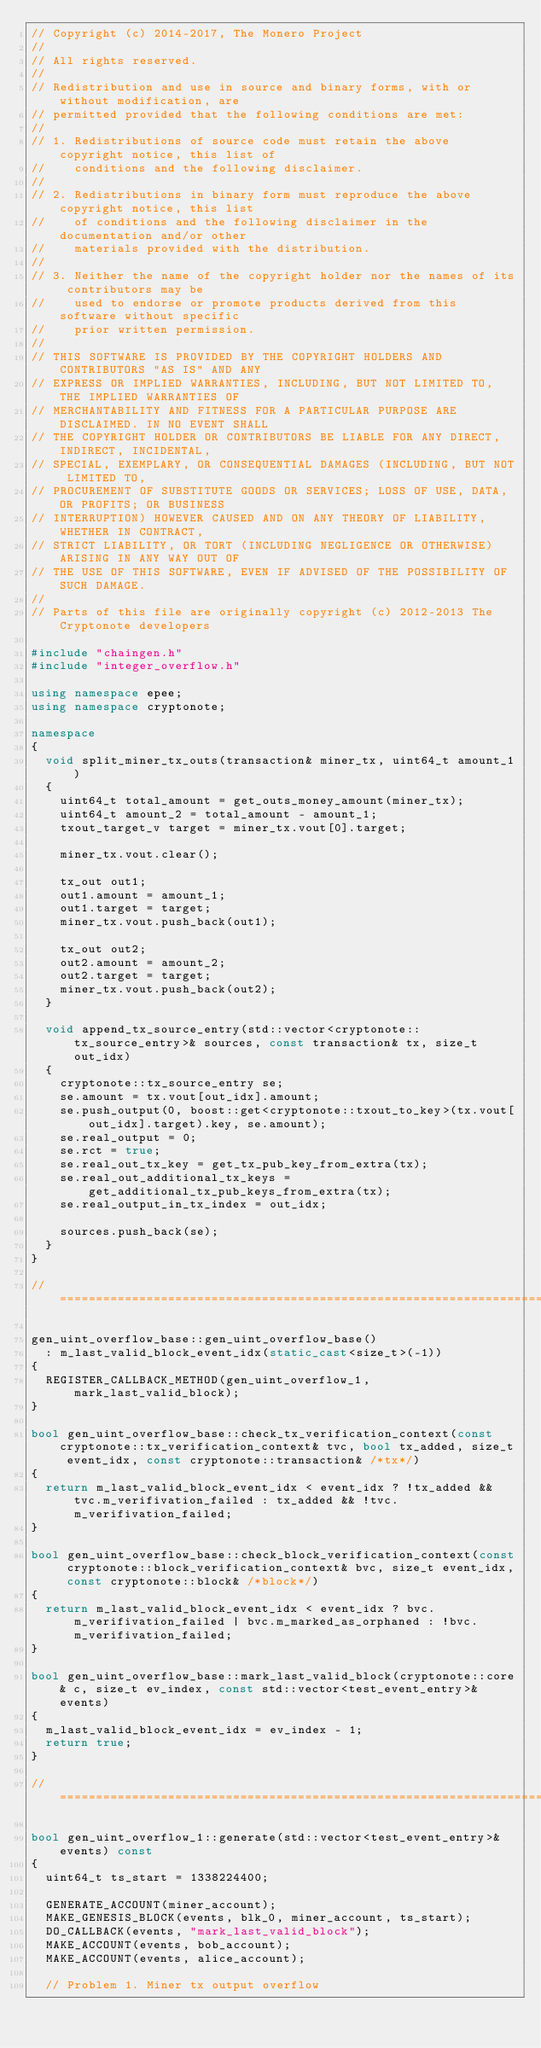<code> <loc_0><loc_0><loc_500><loc_500><_C++_>// Copyright (c) 2014-2017, The Monero Project
//
// All rights reserved.
//
// Redistribution and use in source and binary forms, with or without modification, are
// permitted provided that the following conditions are met:
//
// 1. Redistributions of source code must retain the above copyright notice, this list of
//    conditions and the following disclaimer.
//
// 2. Redistributions in binary form must reproduce the above copyright notice, this list
//    of conditions and the following disclaimer in the documentation and/or other
//    materials provided with the distribution.
//
// 3. Neither the name of the copyright holder nor the names of its contributors may be
//    used to endorse or promote products derived from this software without specific
//    prior written permission.
//
// THIS SOFTWARE IS PROVIDED BY THE COPYRIGHT HOLDERS AND CONTRIBUTORS "AS IS" AND ANY
// EXPRESS OR IMPLIED WARRANTIES, INCLUDING, BUT NOT LIMITED TO, THE IMPLIED WARRANTIES OF
// MERCHANTABILITY AND FITNESS FOR A PARTICULAR PURPOSE ARE DISCLAIMED. IN NO EVENT SHALL
// THE COPYRIGHT HOLDER OR CONTRIBUTORS BE LIABLE FOR ANY DIRECT, INDIRECT, INCIDENTAL,
// SPECIAL, EXEMPLARY, OR CONSEQUENTIAL DAMAGES (INCLUDING, BUT NOT LIMITED TO,
// PROCUREMENT OF SUBSTITUTE GOODS OR SERVICES; LOSS OF USE, DATA, OR PROFITS; OR BUSINESS
// INTERRUPTION) HOWEVER CAUSED AND ON ANY THEORY OF LIABILITY, WHETHER IN CONTRACT,
// STRICT LIABILITY, OR TORT (INCLUDING NEGLIGENCE OR OTHERWISE) ARISING IN ANY WAY OUT OF
// THE USE OF THIS SOFTWARE, EVEN IF ADVISED OF THE POSSIBILITY OF SUCH DAMAGE.
//
// Parts of this file are originally copyright (c) 2012-2013 The Cryptonote developers

#include "chaingen.h"
#include "integer_overflow.h"

using namespace epee;
using namespace cryptonote;

namespace
{
  void split_miner_tx_outs(transaction& miner_tx, uint64_t amount_1)
  {
    uint64_t total_amount = get_outs_money_amount(miner_tx);
    uint64_t amount_2 = total_amount - amount_1;
    txout_target_v target = miner_tx.vout[0].target;

    miner_tx.vout.clear();

    tx_out out1;
    out1.amount = amount_1;
    out1.target = target;
    miner_tx.vout.push_back(out1);

    tx_out out2;
    out2.amount = amount_2;
    out2.target = target;
    miner_tx.vout.push_back(out2);
  }

  void append_tx_source_entry(std::vector<cryptonote::tx_source_entry>& sources, const transaction& tx, size_t out_idx)
  {
    cryptonote::tx_source_entry se;
    se.amount = tx.vout[out_idx].amount;
    se.push_output(0, boost::get<cryptonote::txout_to_key>(tx.vout[out_idx].target).key, se.amount);
    se.real_output = 0;
    se.rct = true;
    se.real_out_tx_key = get_tx_pub_key_from_extra(tx);
    se.real_out_additional_tx_keys = get_additional_tx_pub_keys_from_extra(tx);
    se.real_output_in_tx_index = out_idx;

    sources.push_back(se);
  }
}

//======================================================================================================================

gen_uint_overflow_base::gen_uint_overflow_base()
  : m_last_valid_block_event_idx(static_cast<size_t>(-1))
{
  REGISTER_CALLBACK_METHOD(gen_uint_overflow_1, mark_last_valid_block);
}

bool gen_uint_overflow_base::check_tx_verification_context(const cryptonote::tx_verification_context& tvc, bool tx_added, size_t event_idx, const cryptonote::transaction& /*tx*/)
{
  return m_last_valid_block_event_idx < event_idx ? !tx_added && tvc.m_verifivation_failed : tx_added && !tvc.m_verifivation_failed;
}

bool gen_uint_overflow_base::check_block_verification_context(const cryptonote::block_verification_context& bvc, size_t event_idx, const cryptonote::block& /*block*/)
{
  return m_last_valid_block_event_idx < event_idx ? bvc.m_verifivation_failed | bvc.m_marked_as_orphaned : !bvc.m_verifivation_failed;
}

bool gen_uint_overflow_base::mark_last_valid_block(cryptonote::core& c, size_t ev_index, const std::vector<test_event_entry>& events)
{
  m_last_valid_block_event_idx = ev_index - 1;
  return true;
}

//======================================================================================================================

bool gen_uint_overflow_1::generate(std::vector<test_event_entry>& events) const
{
  uint64_t ts_start = 1338224400;

  GENERATE_ACCOUNT(miner_account);
  MAKE_GENESIS_BLOCK(events, blk_0, miner_account, ts_start);
  DO_CALLBACK(events, "mark_last_valid_block");
  MAKE_ACCOUNT(events, bob_account);
  MAKE_ACCOUNT(events, alice_account);

  // Problem 1. Miner tx output overflow</code> 